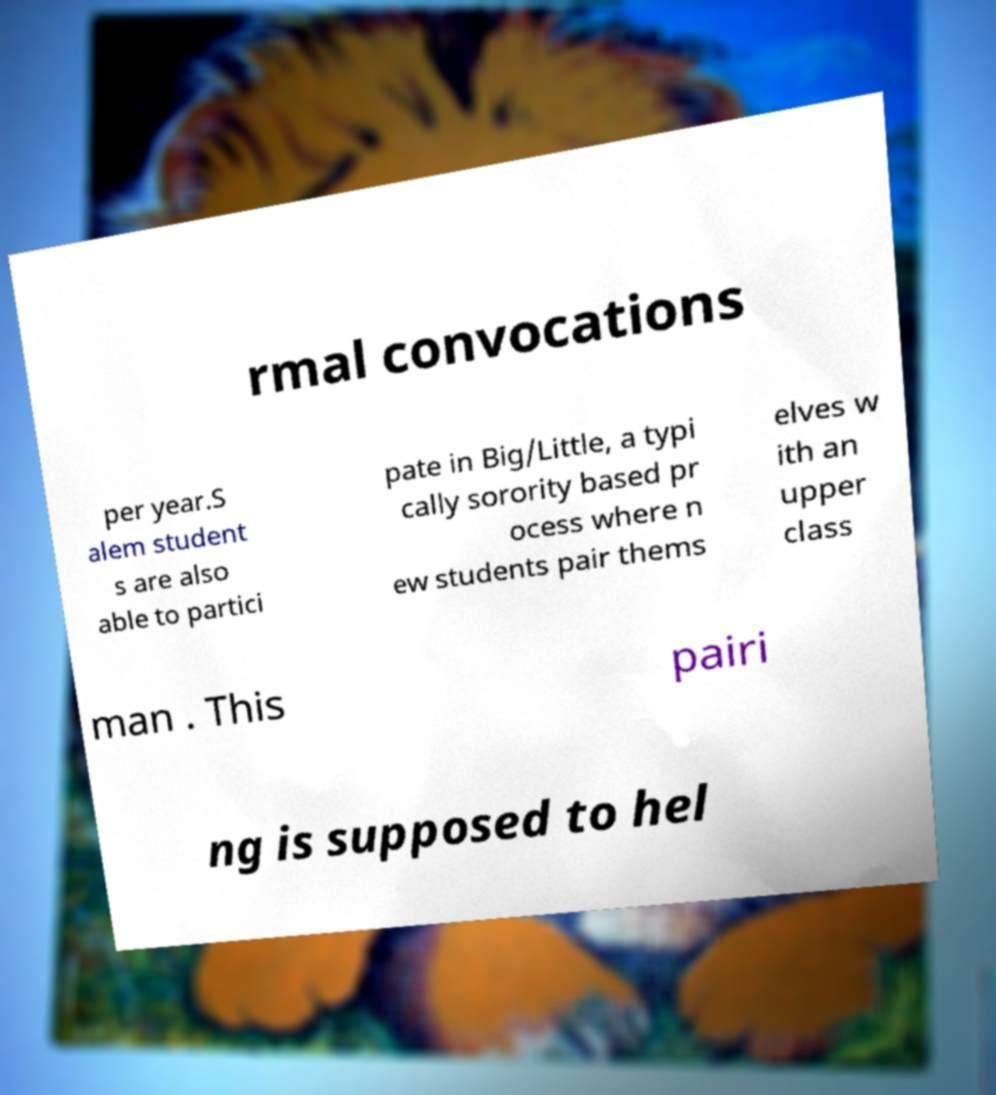Can you accurately transcribe the text from the provided image for me? rmal convocations per year.S alem student s are also able to partici pate in Big/Little, a typi cally sorority based pr ocess where n ew students pair thems elves w ith an upper class man . This pairi ng is supposed to hel 